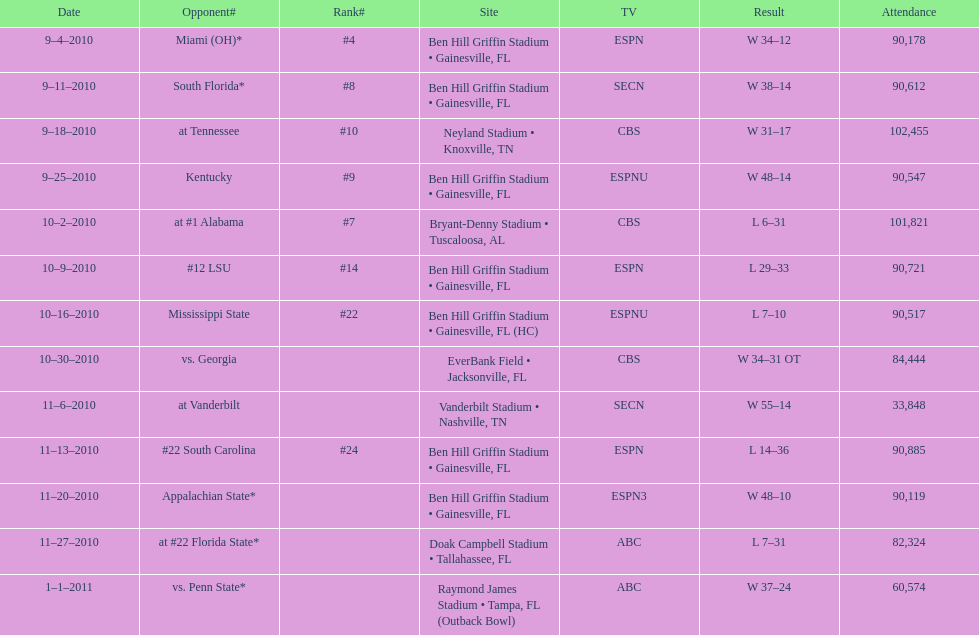How many games were played at the ben hill griffin stadium during the 2010-2011 season? 7. 